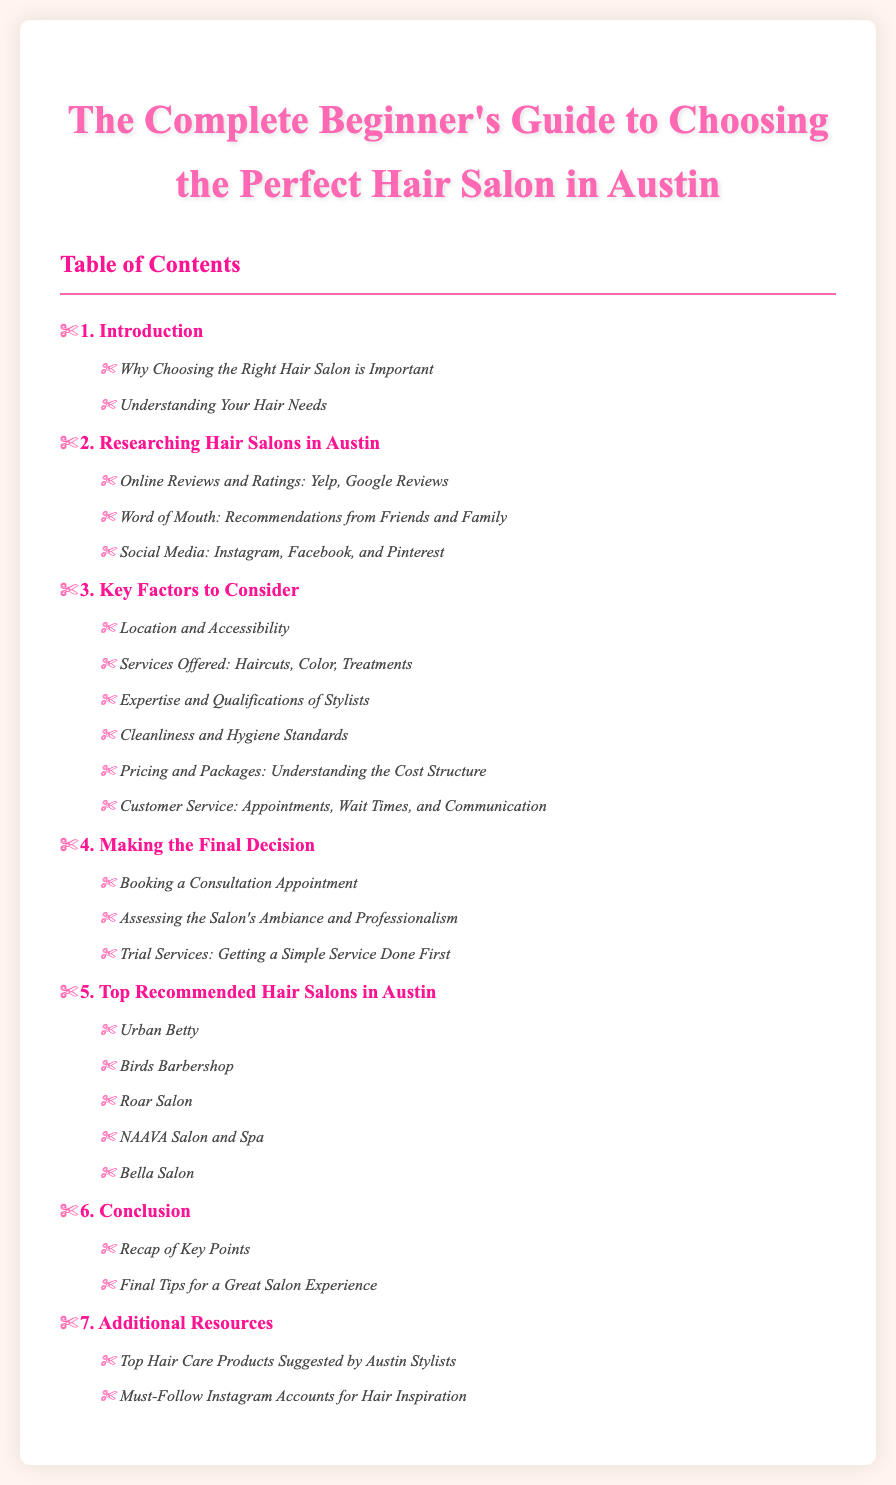What is the title of the document? The title is stated prominently at the top of the rendered document.
Answer: The Complete Beginner's Guide to Choosing the Perfect Hair Salon in Austin How many chapters are there in the Table of Contents? The chapters are listed under the Table of Contents, and there are a total of seven listed.
Answer: 7 What is one key factor to consider when choosing a hair salon? Key factors are listed in Chapter 3, one of which is highlighted.
Answer: Location and Accessibility What is the first recommended hair salon mentioned? The recommended salons are listed in Chapter 5, and the first one is specified.
Answer: Urban Betty What is a suggestion for making a final decision about a hair salon? Suggestions for making a decision are outlined in Chapter 4.
Answer: Booking a Consultation Appointment Which section discusses the importance of understanding your hair needs? This topic is covered in Chapter 1, specifically in the second section.
Answer: Understanding Your Hair Needs What type of resources can you find in the Additional Resources chapter? The Additional Resources chapter includes types of information that can be useful for readers.
Answer: Hair Care Products and Instagram Accounts 